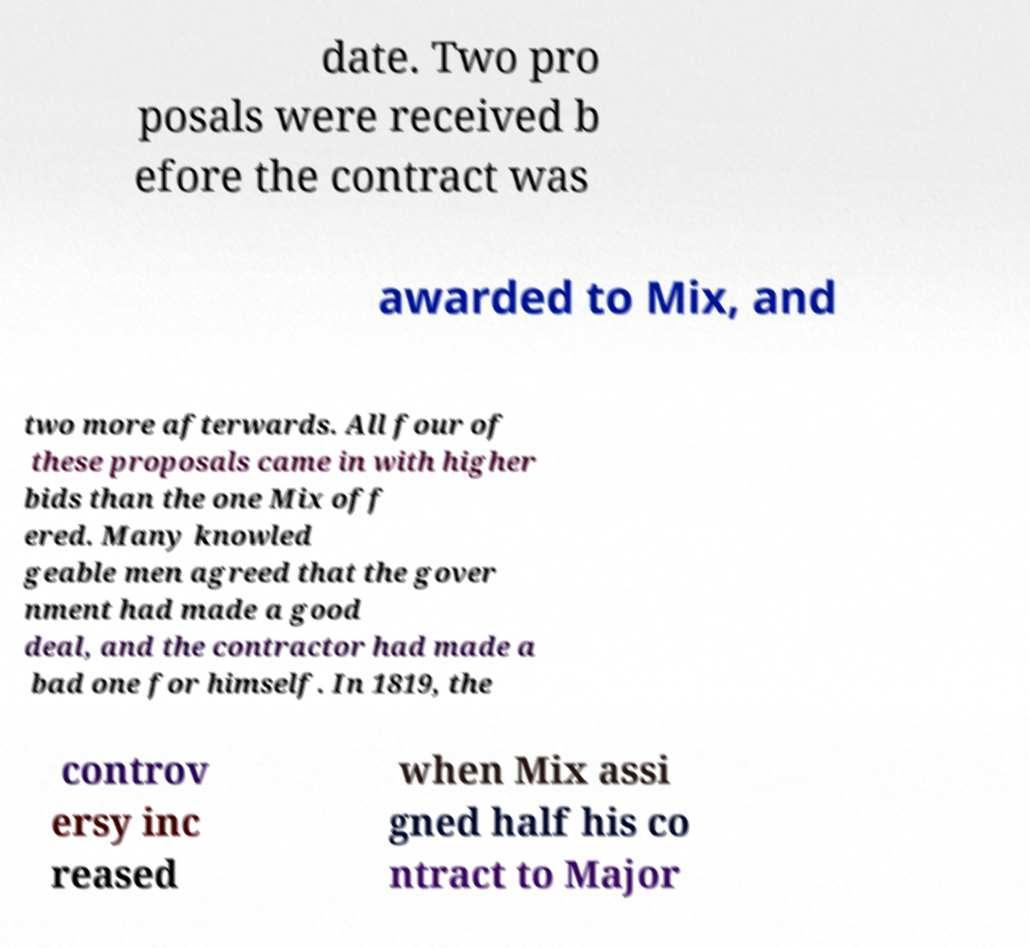There's text embedded in this image that I need extracted. Can you transcribe it verbatim? date. Two pro posals were received b efore the contract was awarded to Mix, and two more afterwards. All four of these proposals came in with higher bids than the one Mix off ered. Many knowled geable men agreed that the gover nment had made a good deal, and the contractor had made a bad one for himself. In 1819, the controv ersy inc reased when Mix assi gned half his co ntract to Major 